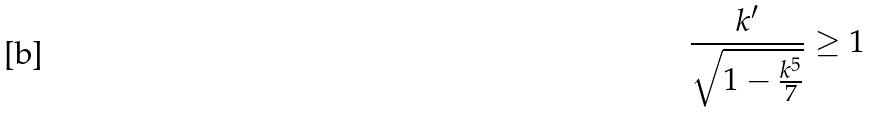<formula> <loc_0><loc_0><loc_500><loc_500>\frac { k ^ { \prime } } { \sqrt { 1 - \frac { k ^ { 5 } } { 7 } } } \geq 1</formula> 